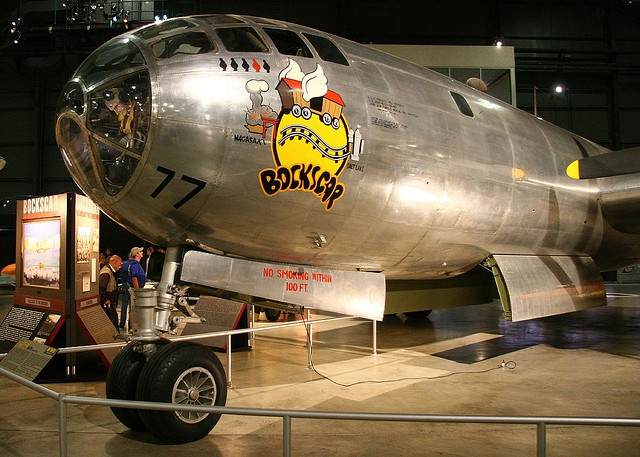Describe the objects in this image and their specific colors. I can see airplane in black, tan, olive, and gray tones, people in black, brown, and maroon tones, people in black, navy, maroon, and gray tones, people in black, navy, brown, and maroon tones, and people in black, maroon, and brown tones in this image. 